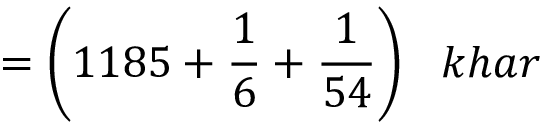Convert formula to latex. <formula><loc_0><loc_0><loc_500><loc_500>= { \left ( } 1 1 8 5 + { \frac { 1 } { 6 } } + { \frac { 1 } { 5 4 } } { \right ) } \, k h a r</formula> 